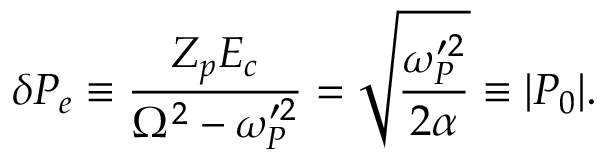<formula> <loc_0><loc_0><loc_500><loc_500>\delta P _ { e } \equiv \frac { Z _ { p } E _ { c } } { \Omega ^ { 2 } - \omega _ { P } ^ { \prime 2 } } = \sqrt { \frac { \omega _ { P } ^ { \prime 2 } } { 2 \alpha } } \equiv | P _ { 0 } | .</formula> 